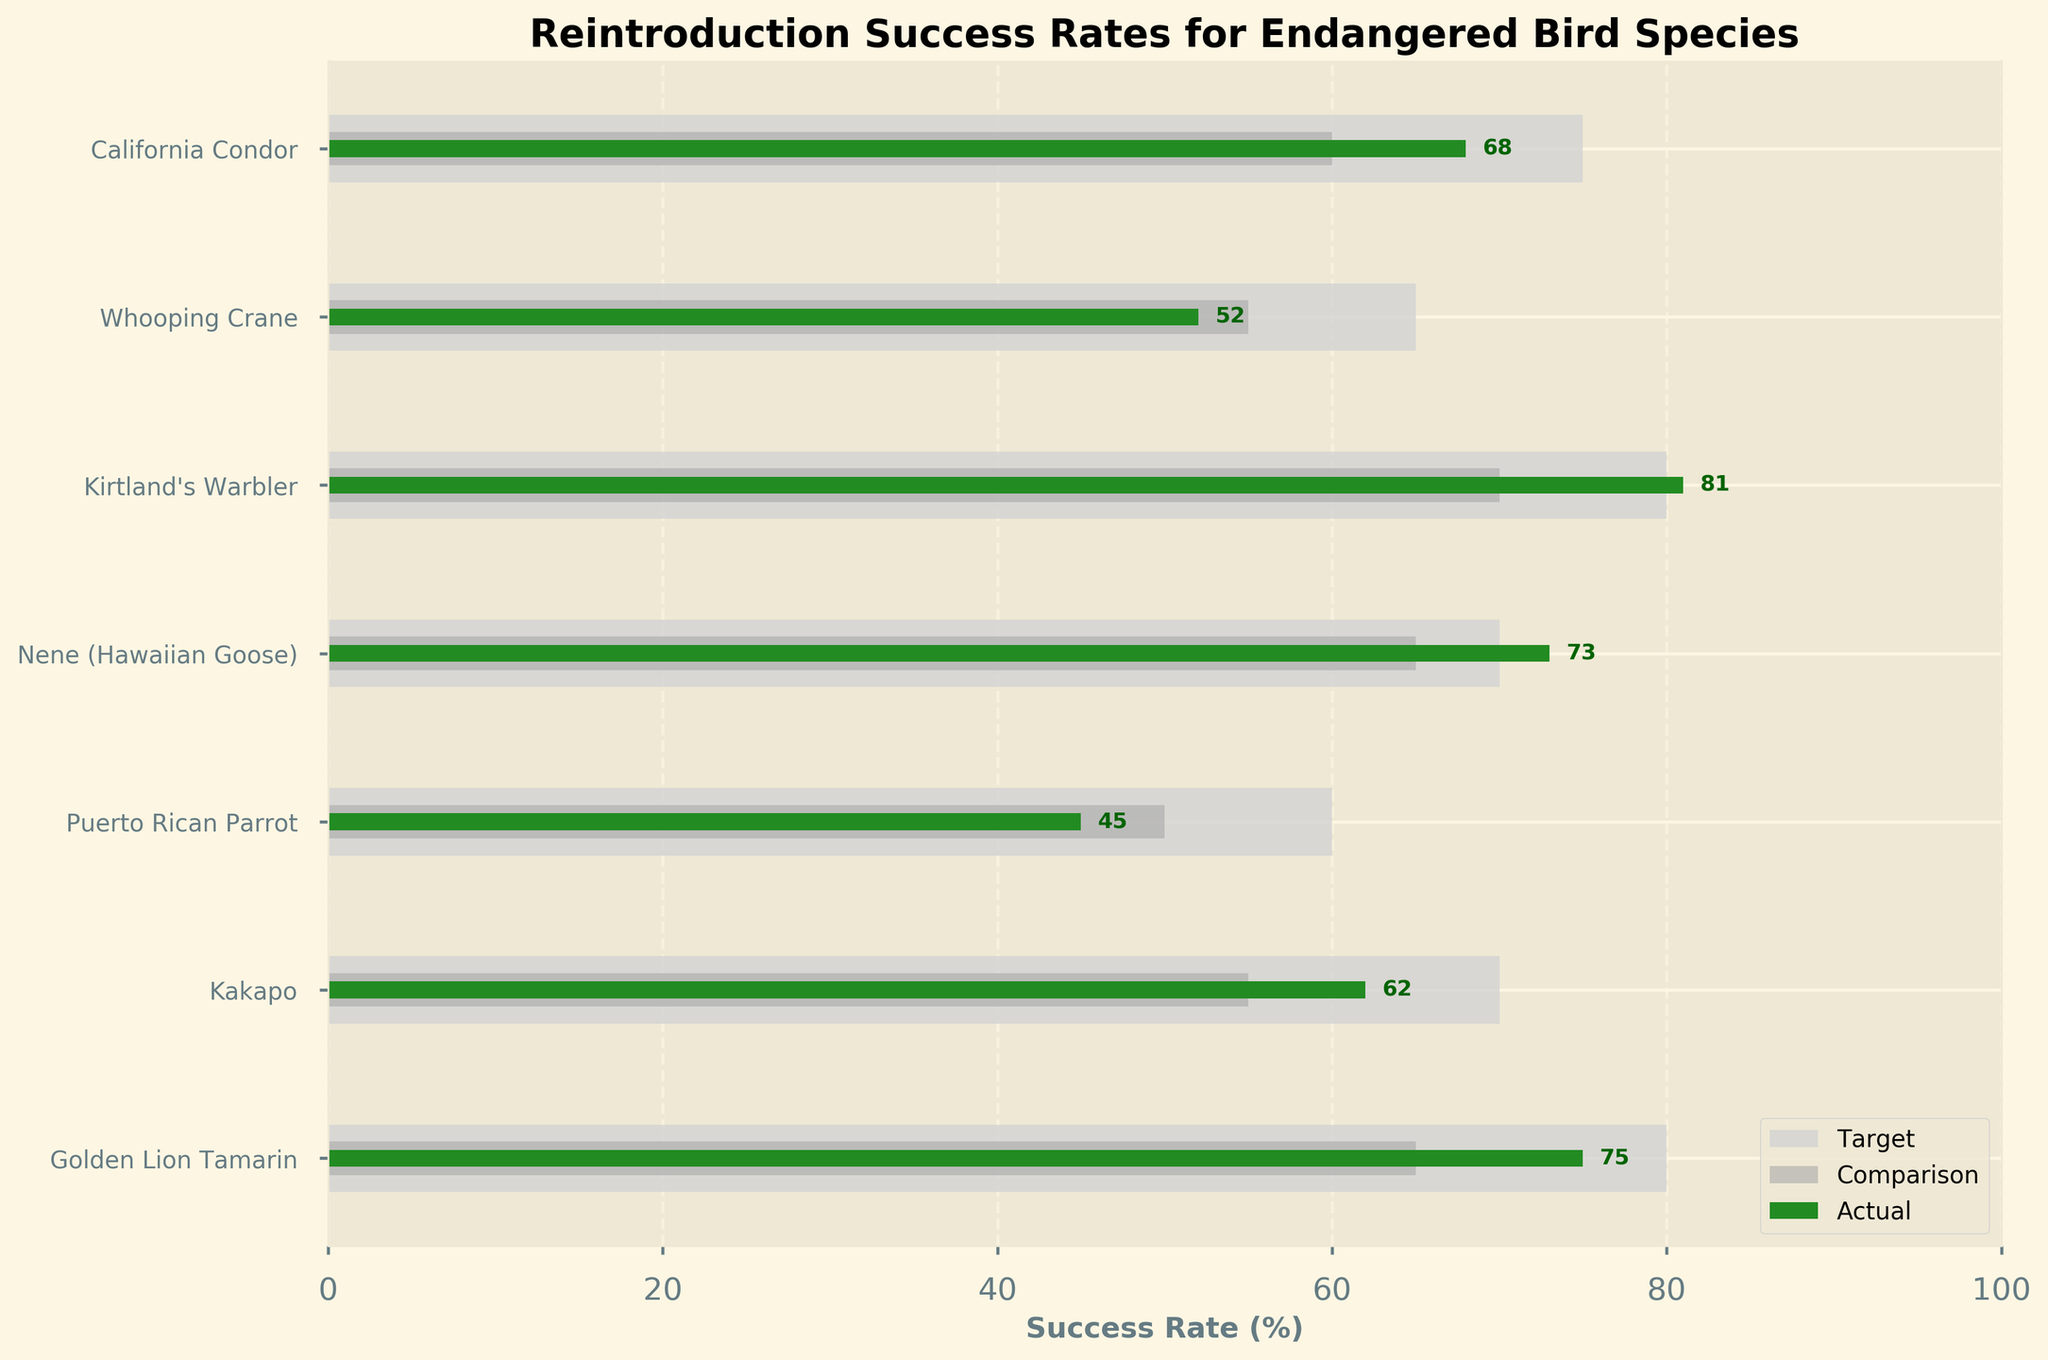What is the title of the chart? The title is displayed prominently at the top of the chart. It reads "Reintroduction Success Rates for Endangered Bird Species".
Answer: Reintroduction Success Rates for Endangered Bird Species Which species has the highest actual success rate? By looking at the "Actual" bars, Kirtland's Warbler has the highest value at 81%.
Answer: Kirtland's Warbler What is the difference between the target and actual success rate for the California Condor? The target success rate for the California Condor is 75%, and the actual success rate is 68%. The difference is 75% - 68% = 7%.
Answer: 7% Which species is the closest to meeting its target success rate? By comparing the target and actual success rates, Kirtland's Warbler has an actual success rate of 81% and a target of 80%, making it closest to its target.
Answer: Kirtland's Warbler What is the average actual success rate for all species? Add all actual success rates (68, 52, 81, 73, 45, 62, 75) and divide by the number of species (7). (68 + 52 + 81 + 73 + 45 + 62 + 75 = 456; 456 / 7 = 65.14).
Answer: 65.14% How many species have an actual success rate above the comparison success rate? By comparing the actual and comparison success rates for each species, there are 5 species (California Condor, Whooping Crane, Nene, Kakapo, and Golden Lion Tamarin) that have actual success rates above their respective comparison success rates.
Answer: 5 Which species has the largest gap between its target and actual success rates? Calculate the gaps for each species: California Condor (7%), Whooping Crane (13%), Kirtland's Warbler (1%), Nene (3%), Puerto Rican Parrot (15%), Kakapo (8%), and Golden Lion Tamarin (5%). The Puerto Rican Parrot has the largest gap at 15%.
Answer: Puerto Rican Parrot Is the actual success rate for the Puerto Rican Parrot above or below its comparison success rate? The actual success rate for the Puerto Rican Parrot is 45%, and its comparison success rate is 50%. Since 45% is less than 50%, it is below.
Answer: Below What is the combined target success rate for the California Condor and the Whooping Crane? The target success rates are 75% for the California Condor and 65% for the Whooping Crane. The combined rate is 75% + 65% = 140%.
Answer: 140% In which species is the comparison success rate higher than the actual success rate? By comparing the actual and comparison success rates, the Puerto Rican Parrot (actual 45%, comparison 50%) is the species where the comparison rate is higher.
Answer: Puerto Rican Parrot 